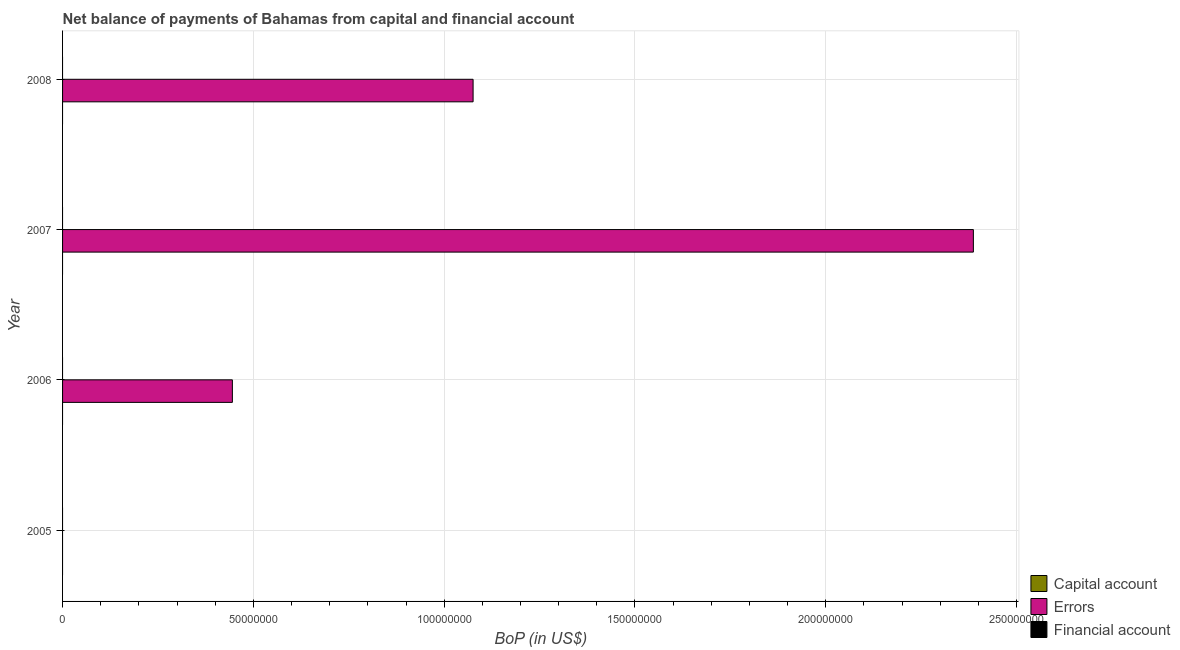How many different coloured bars are there?
Your answer should be compact. 1. Are the number of bars per tick equal to the number of legend labels?
Ensure brevity in your answer.  No. Are the number of bars on each tick of the Y-axis equal?
Your response must be concise. No. How many bars are there on the 3rd tick from the top?
Provide a succinct answer. 1. In how many cases, is the number of bars for a given year not equal to the number of legend labels?
Provide a short and direct response. 4. Across all years, what is the maximum amount of errors?
Your answer should be very brief. 2.39e+08. What is the difference between the amount of errors in 2006 and that in 2007?
Keep it short and to the point. -1.94e+08. What is the average amount of financial account per year?
Make the answer very short. 0. In how many years, is the amount of errors greater than 120000000 US$?
Provide a short and direct response. 1. What is the difference between the highest and the second highest amount of errors?
Make the answer very short. 1.31e+08. What is the difference between the highest and the lowest amount of errors?
Provide a succinct answer. 2.39e+08. How many bars are there?
Offer a very short reply. 3. What is the difference between two consecutive major ticks on the X-axis?
Offer a terse response. 5.00e+07. Where does the legend appear in the graph?
Keep it short and to the point. Bottom right. How many legend labels are there?
Offer a very short reply. 3. How are the legend labels stacked?
Your answer should be compact. Vertical. What is the title of the graph?
Give a very brief answer. Net balance of payments of Bahamas from capital and financial account. What is the label or title of the X-axis?
Keep it short and to the point. BoP (in US$). What is the BoP (in US$) of Errors in 2005?
Your answer should be very brief. 0. What is the BoP (in US$) in Errors in 2006?
Offer a terse response. 4.45e+07. What is the BoP (in US$) of Capital account in 2007?
Give a very brief answer. 0. What is the BoP (in US$) of Errors in 2007?
Offer a terse response. 2.39e+08. What is the BoP (in US$) in Financial account in 2007?
Give a very brief answer. 0. What is the BoP (in US$) of Errors in 2008?
Offer a terse response. 1.08e+08. What is the BoP (in US$) in Financial account in 2008?
Ensure brevity in your answer.  0. Across all years, what is the maximum BoP (in US$) of Errors?
Offer a very short reply. 2.39e+08. What is the total BoP (in US$) of Capital account in the graph?
Keep it short and to the point. 0. What is the total BoP (in US$) of Errors in the graph?
Ensure brevity in your answer.  3.91e+08. What is the difference between the BoP (in US$) in Errors in 2006 and that in 2007?
Your response must be concise. -1.94e+08. What is the difference between the BoP (in US$) in Errors in 2006 and that in 2008?
Keep it short and to the point. -6.31e+07. What is the difference between the BoP (in US$) of Errors in 2007 and that in 2008?
Make the answer very short. 1.31e+08. What is the average BoP (in US$) of Capital account per year?
Ensure brevity in your answer.  0. What is the average BoP (in US$) of Errors per year?
Ensure brevity in your answer.  9.77e+07. What is the average BoP (in US$) of Financial account per year?
Keep it short and to the point. 0. What is the ratio of the BoP (in US$) in Errors in 2006 to that in 2007?
Make the answer very short. 0.19. What is the ratio of the BoP (in US$) in Errors in 2006 to that in 2008?
Your answer should be very brief. 0.41. What is the ratio of the BoP (in US$) in Errors in 2007 to that in 2008?
Your answer should be compact. 2.22. What is the difference between the highest and the second highest BoP (in US$) of Errors?
Your answer should be compact. 1.31e+08. What is the difference between the highest and the lowest BoP (in US$) of Errors?
Your answer should be compact. 2.39e+08. 